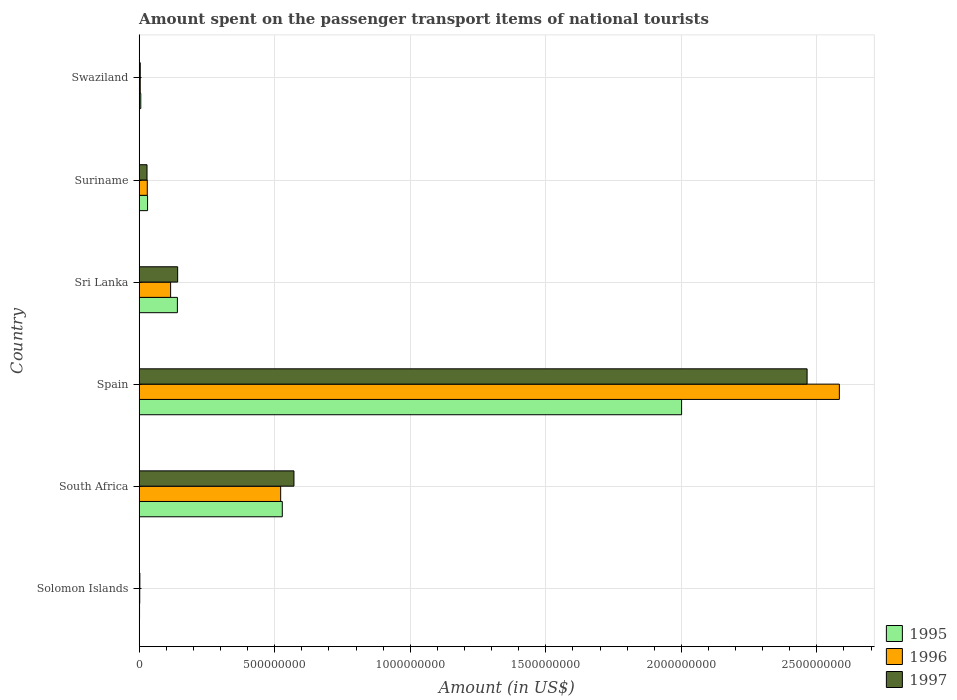How many groups of bars are there?
Ensure brevity in your answer.  6. How many bars are there on the 6th tick from the top?
Keep it short and to the point. 3. How many bars are there on the 4th tick from the bottom?
Offer a terse response. 3. What is the label of the 6th group of bars from the top?
Offer a very short reply. Solomon Islands. What is the amount spent on the passenger transport items of national tourists in 1995 in Sri Lanka?
Your response must be concise. 1.41e+08. Across all countries, what is the maximum amount spent on the passenger transport items of national tourists in 1997?
Provide a short and direct response. 2.46e+09. Across all countries, what is the minimum amount spent on the passenger transport items of national tourists in 1996?
Ensure brevity in your answer.  2.10e+06. In which country was the amount spent on the passenger transport items of national tourists in 1997 minimum?
Your answer should be compact. Solomon Islands. What is the total amount spent on the passenger transport items of national tourists in 1997 in the graph?
Your answer should be compact. 3.21e+09. What is the difference between the amount spent on the passenger transport items of national tourists in 1995 in Solomon Islands and that in Spain?
Provide a short and direct response. -2.00e+09. What is the difference between the amount spent on the passenger transport items of national tourists in 1995 in Solomon Islands and the amount spent on the passenger transport items of national tourists in 1997 in Suriname?
Provide a short and direct response. -2.76e+07. What is the average amount spent on the passenger transport items of national tourists in 1996 per country?
Give a very brief answer. 5.43e+08. In how many countries, is the amount spent on the passenger transport items of national tourists in 1996 greater than 2100000000 US$?
Keep it short and to the point. 1. What is the ratio of the amount spent on the passenger transport items of national tourists in 1996 in Solomon Islands to that in Swaziland?
Your answer should be very brief. 0.53. Is the amount spent on the passenger transport items of national tourists in 1997 in South Africa less than that in Spain?
Offer a very short reply. Yes. Is the difference between the amount spent on the passenger transport items of national tourists in 1997 in South Africa and Swaziland greater than the difference between the amount spent on the passenger transport items of national tourists in 1995 in South Africa and Swaziland?
Provide a short and direct response. Yes. What is the difference between the highest and the second highest amount spent on the passenger transport items of national tourists in 1996?
Your response must be concise. 2.06e+09. What is the difference between the highest and the lowest amount spent on the passenger transport items of national tourists in 1995?
Your response must be concise. 2.00e+09. Is the sum of the amount spent on the passenger transport items of national tourists in 1995 in Sri Lanka and Swaziland greater than the maximum amount spent on the passenger transport items of national tourists in 1997 across all countries?
Your response must be concise. No. What does the 1st bar from the bottom in Sri Lanka represents?
Your answer should be compact. 1995. Are all the bars in the graph horizontal?
Provide a succinct answer. Yes. How many countries are there in the graph?
Offer a terse response. 6. Are the values on the major ticks of X-axis written in scientific E-notation?
Your answer should be compact. No. Does the graph contain grids?
Give a very brief answer. Yes. Where does the legend appear in the graph?
Make the answer very short. Bottom right. How are the legend labels stacked?
Provide a succinct answer. Vertical. What is the title of the graph?
Keep it short and to the point. Amount spent on the passenger transport items of national tourists. What is the label or title of the X-axis?
Offer a very short reply. Amount (in US$). What is the Amount (in US$) of 1995 in Solomon Islands?
Provide a succinct answer. 1.40e+06. What is the Amount (in US$) in 1996 in Solomon Islands?
Provide a short and direct response. 2.10e+06. What is the Amount (in US$) of 1997 in Solomon Islands?
Make the answer very short. 2.60e+06. What is the Amount (in US$) of 1995 in South Africa?
Keep it short and to the point. 5.28e+08. What is the Amount (in US$) in 1996 in South Africa?
Your answer should be compact. 5.22e+08. What is the Amount (in US$) in 1997 in South Africa?
Your answer should be compact. 5.71e+08. What is the Amount (in US$) in 1995 in Spain?
Make the answer very short. 2.00e+09. What is the Amount (in US$) in 1996 in Spain?
Your answer should be compact. 2.58e+09. What is the Amount (in US$) of 1997 in Spain?
Your answer should be compact. 2.46e+09. What is the Amount (in US$) of 1995 in Sri Lanka?
Provide a succinct answer. 1.41e+08. What is the Amount (in US$) in 1996 in Sri Lanka?
Ensure brevity in your answer.  1.16e+08. What is the Amount (in US$) in 1997 in Sri Lanka?
Provide a short and direct response. 1.42e+08. What is the Amount (in US$) in 1995 in Suriname?
Keep it short and to the point. 3.10e+07. What is the Amount (in US$) of 1996 in Suriname?
Your answer should be compact. 3.00e+07. What is the Amount (in US$) of 1997 in Suriname?
Provide a succinct answer. 2.90e+07. What is the Amount (in US$) of 1995 in Swaziland?
Provide a succinct answer. 6.00e+06. Across all countries, what is the maximum Amount (in US$) in 1995?
Your response must be concise. 2.00e+09. Across all countries, what is the maximum Amount (in US$) of 1996?
Provide a succinct answer. 2.58e+09. Across all countries, what is the maximum Amount (in US$) of 1997?
Offer a terse response. 2.46e+09. Across all countries, what is the minimum Amount (in US$) of 1995?
Keep it short and to the point. 1.40e+06. Across all countries, what is the minimum Amount (in US$) in 1996?
Offer a terse response. 2.10e+06. Across all countries, what is the minimum Amount (in US$) of 1997?
Give a very brief answer. 2.60e+06. What is the total Amount (in US$) of 1995 in the graph?
Offer a very short reply. 2.71e+09. What is the total Amount (in US$) in 1996 in the graph?
Provide a succinct answer. 3.26e+09. What is the total Amount (in US$) in 1997 in the graph?
Keep it short and to the point. 3.21e+09. What is the difference between the Amount (in US$) of 1995 in Solomon Islands and that in South Africa?
Ensure brevity in your answer.  -5.27e+08. What is the difference between the Amount (in US$) in 1996 in Solomon Islands and that in South Africa?
Provide a succinct answer. -5.20e+08. What is the difference between the Amount (in US$) in 1997 in Solomon Islands and that in South Africa?
Offer a very short reply. -5.68e+08. What is the difference between the Amount (in US$) of 1995 in Solomon Islands and that in Spain?
Ensure brevity in your answer.  -2.00e+09. What is the difference between the Amount (in US$) in 1996 in Solomon Islands and that in Spain?
Provide a succinct answer. -2.58e+09. What is the difference between the Amount (in US$) in 1997 in Solomon Islands and that in Spain?
Your response must be concise. -2.46e+09. What is the difference between the Amount (in US$) in 1995 in Solomon Islands and that in Sri Lanka?
Give a very brief answer. -1.40e+08. What is the difference between the Amount (in US$) in 1996 in Solomon Islands and that in Sri Lanka?
Your response must be concise. -1.14e+08. What is the difference between the Amount (in US$) of 1997 in Solomon Islands and that in Sri Lanka?
Offer a terse response. -1.39e+08. What is the difference between the Amount (in US$) of 1995 in Solomon Islands and that in Suriname?
Your response must be concise. -2.96e+07. What is the difference between the Amount (in US$) of 1996 in Solomon Islands and that in Suriname?
Your response must be concise. -2.79e+07. What is the difference between the Amount (in US$) of 1997 in Solomon Islands and that in Suriname?
Provide a succinct answer. -2.64e+07. What is the difference between the Amount (in US$) of 1995 in Solomon Islands and that in Swaziland?
Provide a succinct answer. -4.60e+06. What is the difference between the Amount (in US$) in 1996 in Solomon Islands and that in Swaziland?
Make the answer very short. -1.90e+06. What is the difference between the Amount (in US$) in 1997 in Solomon Islands and that in Swaziland?
Make the answer very short. -1.40e+06. What is the difference between the Amount (in US$) of 1995 in South Africa and that in Spain?
Provide a short and direct response. -1.47e+09. What is the difference between the Amount (in US$) in 1996 in South Africa and that in Spain?
Make the answer very short. -2.06e+09. What is the difference between the Amount (in US$) in 1997 in South Africa and that in Spain?
Provide a short and direct response. -1.89e+09. What is the difference between the Amount (in US$) in 1995 in South Africa and that in Sri Lanka?
Keep it short and to the point. 3.87e+08. What is the difference between the Amount (in US$) of 1996 in South Africa and that in Sri Lanka?
Your response must be concise. 4.06e+08. What is the difference between the Amount (in US$) of 1997 in South Africa and that in Sri Lanka?
Your response must be concise. 4.29e+08. What is the difference between the Amount (in US$) in 1995 in South Africa and that in Suriname?
Keep it short and to the point. 4.97e+08. What is the difference between the Amount (in US$) in 1996 in South Africa and that in Suriname?
Provide a short and direct response. 4.92e+08. What is the difference between the Amount (in US$) of 1997 in South Africa and that in Suriname?
Your response must be concise. 5.42e+08. What is the difference between the Amount (in US$) in 1995 in South Africa and that in Swaziland?
Provide a succinct answer. 5.22e+08. What is the difference between the Amount (in US$) of 1996 in South Africa and that in Swaziland?
Make the answer very short. 5.18e+08. What is the difference between the Amount (in US$) of 1997 in South Africa and that in Swaziland?
Provide a succinct answer. 5.67e+08. What is the difference between the Amount (in US$) of 1995 in Spain and that in Sri Lanka?
Make the answer very short. 1.86e+09. What is the difference between the Amount (in US$) of 1996 in Spain and that in Sri Lanka?
Provide a short and direct response. 2.47e+09. What is the difference between the Amount (in US$) of 1997 in Spain and that in Sri Lanka?
Offer a terse response. 2.32e+09. What is the difference between the Amount (in US$) of 1995 in Spain and that in Suriname?
Give a very brief answer. 1.97e+09. What is the difference between the Amount (in US$) in 1996 in Spain and that in Suriname?
Your answer should be very brief. 2.55e+09. What is the difference between the Amount (in US$) of 1997 in Spain and that in Suriname?
Offer a terse response. 2.44e+09. What is the difference between the Amount (in US$) of 1995 in Spain and that in Swaziland?
Keep it short and to the point. 2.00e+09. What is the difference between the Amount (in US$) in 1996 in Spain and that in Swaziland?
Your response must be concise. 2.58e+09. What is the difference between the Amount (in US$) in 1997 in Spain and that in Swaziland?
Ensure brevity in your answer.  2.46e+09. What is the difference between the Amount (in US$) in 1995 in Sri Lanka and that in Suriname?
Your response must be concise. 1.10e+08. What is the difference between the Amount (in US$) of 1996 in Sri Lanka and that in Suriname?
Provide a succinct answer. 8.60e+07. What is the difference between the Amount (in US$) in 1997 in Sri Lanka and that in Suriname?
Offer a terse response. 1.13e+08. What is the difference between the Amount (in US$) in 1995 in Sri Lanka and that in Swaziland?
Your answer should be very brief. 1.35e+08. What is the difference between the Amount (in US$) in 1996 in Sri Lanka and that in Swaziland?
Offer a very short reply. 1.12e+08. What is the difference between the Amount (in US$) of 1997 in Sri Lanka and that in Swaziland?
Provide a succinct answer. 1.38e+08. What is the difference between the Amount (in US$) in 1995 in Suriname and that in Swaziland?
Offer a terse response. 2.50e+07. What is the difference between the Amount (in US$) of 1996 in Suriname and that in Swaziland?
Offer a very short reply. 2.60e+07. What is the difference between the Amount (in US$) in 1997 in Suriname and that in Swaziland?
Provide a short and direct response. 2.50e+07. What is the difference between the Amount (in US$) of 1995 in Solomon Islands and the Amount (in US$) of 1996 in South Africa?
Keep it short and to the point. -5.21e+08. What is the difference between the Amount (in US$) in 1995 in Solomon Islands and the Amount (in US$) in 1997 in South Africa?
Provide a succinct answer. -5.70e+08. What is the difference between the Amount (in US$) in 1996 in Solomon Islands and the Amount (in US$) in 1997 in South Africa?
Your answer should be compact. -5.69e+08. What is the difference between the Amount (in US$) of 1995 in Solomon Islands and the Amount (in US$) of 1996 in Spain?
Your answer should be compact. -2.58e+09. What is the difference between the Amount (in US$) of 1995 in Solomon Islands and the Amount (in US$) of 1997 in Spain?
Give a very brief answer. -2.46e+09. What is the difference between the Amount (in US$) in 1996 in Solomon Islands and the Amount (in US$) in 1997 in Spain?
Your response must be concise. -2.46e+09. What is the difference between the Amount (in US$) in 1995 in Solomon Islands and the Amount (in US$) in 1996 in Sri Lanka?
Ensure brevity in your answer.  -1.15e+08. What is the difference between the Amount (in US$) of 1995 in Solomon Islands and the Amount (in US$) of 1997 in Sri Lanka?
Your answer should be compact. -1.41e+08. What is the difference between the Amount (in US$) of 1996 in Solomon Islands and the Amount (in US$) of 1997 in Sri Lanka?
Ensure brevity in your answer.  -1.40e+08. What is the difference between the Amount (in US$) of 1995 in Solomon Islands and the Amount (in US$) of 1996 in Suriname?
Ensure brevity in your answer.  -2.86e+07. What is the difference between the Amount (in US$) of 1995 in Solomon Islands and the Amount (in US$) of 1997 in Suriname?
Ensure brevity in your answer.  -2.76e+07. What is the difference between the Amount (in US$) in 1996 in Solomon Islands and the Amount (in US$) in 1997 in Suriname?
Offer a very short reply. -2.69e+07. What is the difference between the Amount (in US$) in 1995 in Solomon Islands and the Amount (in US$) in 1996 in Swaziland?
Keep it short and to the point. -2.60e+06. What is the difference between the Amount (in US$) in 1995 in Solomon Islands and the Amount (in US$) in 1997 in Swaziland?
Your answer should be compact. -2.60e+06. What is the difference between the Amount (in US$) in 1996 in Solomon Islands and the Amount (in US$) in 1997 in Swaziland?
Ensure brevity in your answer.  -1.90e+06. What is the difference between the Amount (in US$) in 1995 in South Africa and the Amount (in US$) in 1996 in Spain?
Your answer should be compact. -2.06e+09. What is the difference between the Amount (in US$) in 1995 in South Africa and the Amount (in US$) in 1997 in Spain?
Offer a terse response. -1.94e+09. What is the difference between the Amount (in US$) in 1996 in South Africa and the Amount (in US$) in 1997 in Spain?
Keep it short and to the point. -1.94e+09. What is the difference between the Amount (in US$) of 1995 in South Africa and the Amount (in US$) of 1996 in Sri Lanka?
Provide a succinct answer. 4.12e+08. What is the difference between the Amount (in US$) in 1995 in South Africa and the Amount (in US$) in 1997 in Sri Lanka?
Ensure brevity in your answer.  3.86e+08. What is the difference between the Amount (in US$) of 1996 in South Africa and the Amount (in US$) of 1997 in Sri Lanka?
Keep it short and to the point. 3.80e+08. What is the difference between the Amount (in US$) of 1995 in South Africa and the Amount (in US$) of 1996 in Suriname?
Make the answer very short. 4.98e+08. What is the difference between the Amount (in US$) in 1995 in South Africa and the Amount (in US$) in 1997 in Suriname?
Provide a succinct answer. 4.99e+08. What is the difference between the Amount (in US$) in 1996 in South Africa and the Amount (in US$) in 1997 in Suriname?
Provide a succinct answer. 4.93e+08. What is the difference between the Amount (in US$) in 1995 in South Africa and the Amount (in US$) in 1996 in Swaziland?
Offer a very short reply. 5.24e+08. What is the difference between the Amount (in US$) in 1995 in South Africa and the Amount (in US$) in 1997 in Swaziland?
Offer a very short reply. 5.24e+08. What is the difference between the Amount (in US$) of 1996 in South Africa and the Amount (in US$) of 1997 in Swaziland?
Offer a very short reply. 5.18e+08. What is the difference between the Amount (in US$) of 1995 in Spain and the Amount (in US$) of 1996 in Sri Lanka?
Your answer should be very brief. 1.88e+09. What is the difference between the Amount (in US$) in 1995 in Spain and the Amount (in US$) in 1997 in Sri Lanka?
Your answer should be very brief. 1.86e+09. What is the difference between the Amount (in US$) of 1996 in Spain and the Amount (in US$) of 1997 in Sri Lanka?
Provide a succinct answer. 2.44e+09. What is the difference between the Amount (in US$) in 1995 in Spain and the Amount (in US$) in 1996 in Suriname?
Offer a terse response. 1.97e+09. What is the difference between the Amount (in US$) of 1995 in Spain and the Amount (in US$) of 1997 in Suriname?
Your answer should be compact. 1.97e+09. What is the difference between the Amount (in US$) in 1996 in Spain and the Amount (in US$) in 1997 in Suriname?
Give a very brief answer. 2.55e+09. What is the difference between the Amount (in US$) in 1995 in Spain and the Amount (in US$) in 1996 in Swaziland?
Ensure brevity in your answer.  2.00e+09. What is the difference between the Amount (in US$) in 1995 in Spain and the Amount (in US$) in 1997 in Swaziland?
Your answer should be compact. 2.00e+09. What is the difference between the Amount (in US$) in 1996 in Spain and the Amount (in US$) in 1997 in Swaziland?
Your answer should be compact. 2.58e+09. What is the difference between the Amount (in US$) in 1995 in Sri Lanka and the Amount (in US$) in 1996 in Suriname?
Give a very brief answer. 1.11e+08. What is the difference between the Amount (in US$) of 1995 in Sri Lanka and the Amount (in US$) of 1997 in Suriname?
Make the answer very short. 1.12e+08. What is the difference between the Amount (in US$) of 1996 in Sri Lanka and the Amount (in US$) of 1997 in Suriname?
Provide a short and direct response. 8.70e+07. What is the difference between the Amount (in US$) in 1995 in Sri Lanka and the Amount (in US$) in 1996 in Swaziland?
Ensure brevity in your answer.  1.37e+08. What is the difference between the Amount (in US$) in 1995 in Sri Lanka and the Amount (in US$) in 1997 in Swaziland?
Give a very brief answer. 1.37e+08. What is the difference between the Amount (in US$) of 1996 in Sri Lanka and the Amount (in US$) of 1997 in Swaziland?
Give a very brief answer. 1.12e+08. What is the difference between the Amount (in US$) of 1995 in Suriname and the Amount (in US$) of 1996 in Swaziland?
Offer a very short reply. 2.70e+07. What is the difference between the Amount (in US$) of 1995 in Suriname and the Amount (in US$) of 1997 in Swaziland?
Offer a very short reply. 2.70e+07. What is the difference between the Amount (in US$) of 1996 in Suriname and the Amount (in US$) of 1997 in Swaziland?
Provide a short and direct response. 2.60e+07. What is the average Amount (in US$) of 1995 per country?
Your response must be concise. 4.51e+08. What is the average Amount (in US$) in 1996 per country?
Your answer should be compact. 5.43e+08. What is the average Amount (in US$) of 1997 per country?
Make the answer very short. 5.35e+08. What is the difference between the Amount (in US$) of 1995 and Amount (in US$) of 1996 in Solomon Islands?
Offer a very short reply. -7.00e+05. What is the difference between the Amount (in US$) of 1995 and Amount (in US$) of 1997 in Solomon Islands?
Provide a short and direct response. -1.20e+06. What is the difference between the Amount (in US$) of 1996 and Amount (in US$) of 1997 in Solomon Islands?
Your answer should be very brief. -5.00e+05. What is the difference between the Amount (in US$) of 1995 and Amount (in US$) of 1997 in South Africa?
Provide a short and direct response. -4.30e+07. What is the difference between the Amount (in US$) of 1996 and Amount (in US$) of 1997 in South Africa?
Ensure brevity in your answer.  -4.90e+07. What is the difference between the Amount (in US$) in 1995 and Amount (in US$) in 1996 in Spain?
Provide a short and direct response. -5.82e+08. What is the difference between the Amount (in US$) in 1995 and Amount (in US$) in 1997 in Spain?
Offer a terse response. -4.63e+08. What is the difference between the Amount (in US$) in 1996 and Amount (in US$) in 1997 in Spain?
Your answer should be compact. 1.19e+08. What is the difference between the Amount (in US$) of 1995 and Amount (in US$) of 1996 in Sri Lanka?
Make the answer very short. 2.50e+07. What is the difference between the Amount (in US$) of 1995 and Amount (in US$) of 1997 in Sri Lanka?
Your answer should be compact. -1.00e+06. What is the difference between the Amount (in US$) in 1996 and Amount (in US$) in 1997 in Sri Lanka?
Your answer should be very brief. -2.60e+07. What is the difference between the Amount (in US$) of 1995 and Amount (in US$) of 1997 in Suriname?
Your answer should be compact. 2.00e+06. What is the difference between the Amount (in US$) of 1996 and Amount (in US$) of 1997 in Suriname?
Ensure brevity in your answer.  1.00e+06. What is the difference between the Amount (in US$) in 1995 and Amount (in US$) in 1996 in Swaziland?
Make the answer very short. 2.00e+06. What is the difference between the Amount (in US$) of 1995 and Amount (in US$) of 1997 in Swaziland?
Offer a terse response. 2.00e+06. What is the difference between the Amount (in US$) in 1996 and Amount (in US$) in 1997 in Swaziland?
Make the answer very short. 0. What is the ratio of the Amount (in US$) of 1995 in Solomon Islands to that in South Africa?
Keep it short and to the point. 0. What is the ratio of the Amount (in US$) in 1996 in Solomon Islands to that in South Africa?
Offer a very short reply. 0. What is the ratio of the Amount (in US$) in 1997 in Solomon Islands to that in South Africa?
Your response must be concise. 0. What is the ratio of the Amount (in US$) in 1995 in Solomon Islands to that in Spain?
Your answer should be compact. 0. What is the ratio of the Amount (in US$) in 1996 in Solomon Islands to that in Spain?
Give a very brief answer. 0. What is the ratio of the Amount (in US$) of 1997 in Solomon Islands to that in Spain?
Keep it short and to the point. 0. What is the ratio of the Amount (in US$) in 1995 in Solomon Islands to that in Sri Lanka?
Offer a terse response. 0.01. What is the ratio of the Amount (in US$) of 1996 in Solomon Islands to that in Sri Lanka?
Give a very brief answer. 0.02. What is the ratio of the Amount (in US$) in 1997 in Solomon Islands to that in Sri Lanka?
Your answer should be very brief. 0.02. What is the ratio of the Amount (in US$) of 1995 in Solomon Islands to that in Suriname?
Give a very brief answer. 0.05. What is the ratio of the Amount (in US$) of 1996 in Solomon Islands to that in Suriname?
Make the answer very short. 0.07. What is the ratio of the Amount (in US$) in 1997 in Solomon Islands to that in Suriname?
Your answer should be very brief. 0.09. What is the ratio of the Amount (in US$) of 1995 in Solomon Islands to that in Swaziland?
Provide a succinct answer. 0.23. What is the ratio of the Amount (in US$) in 1996 in Solomon Islands to that in Swaziland?
Make the answer very short. 0.53. What is the ratio of the Amount (in US$) of 1997 in Solomon Islands to that in Swaziland?
Your answer should be compact. 0.65. What is the ratio of the Amount (in US$) of 1995 in South Africa to that in Spain?
Your answer should be very brief. 0.26. What is the ratio of the Amount (in US$) in 1996 in South Africa to that in Spain?
Offer a very short reply. 0.2. What is the ratio of the Amount (in US$) of 1997 in South Africa to that in Spain?
Your answer should be compact. 0.23. What is the ratio of the Amount (in US$) in 1995 in South Africa to that in Sri Lanka?
Your response must be concise. 3.74. What is the ratio of the Amount (in US$) of 1996 in South Africa to that in Sri Lanka?
Offer a terse response. 4.5. What is the ratio of the Amount (in US$) of 1997 in South Africa to that in Sri Lanka?
Offer a terse response. 4.02. What is the ratio of the Amount (in US$) in 1995 in South Africa to that in Suriname?
Provide a succinct answer. 17.03. What is the ratio of the Amount (in US$) in 1997 in South Africa to that in Suriname?
Provide a succinct answer. 19.69. What is the ratio of the Amount (in US$) of 1995 in South Africa to that in Swaziland?
Provide a short and direct response. 88. What is the ratio of the Amount (in US$) in 1996 in South Africa to that in Swaziland?
Your response must be concise. 130.5. What is the ratio of the Amount (in US$) of 1997 in South Africa to that in Swaziland?
Keep it short and to the point. 142.75. What is the ratio of the Amount (in US$) of 1995 in Spain to that in Sri Lanka?
Your answer should be very brief. 14.19. What is the ratio of the Amount (in US$) of 1996 in Spain to that in Sri Lanka?
Offer a very short reply. 22.27. What is the ratio of the Amount (in US$) of 1997 in Spain to that in Sri Lanka?
Make the answer very short. 17.35. What is the ratio of the Amount (in US$) in 1995 in Spain to that in Suriname?
Your response must be concise. 64.55. What is the ratio of the Amount (in US$) in 1996 in Spain to that in Suriname?
Your answer should be compact. 86.1. What is the ratio of the Amount (in US$) of 1997 in Spain to that in Suriname?
Keep it short and to the point. 84.97. What is the ratio of the Amount (in US$) of 1995 in Spain to that in Swaziland?
Keep it short and to the point. 333.5. What is the ratio of the Amount (in US$) in 1996 in Spain to that in Swaziland?
Your answer should be compact. 645.75. What is the ratio of the Amount (in US$) of 1997 in Spain to that in Swaziland?
Make the answer very short. 616. What is the ratio of the Amount (in US$) in 1995 in Sri Lanka to that in Suriname?
Offer a terse response. 4.55. What is the ratio of the Amount (in US$) in 1996 in Sri Lanka to that in Suriname?
Your answer should be compact. 3.87. What is the ratio of the Amount (in US$) of 1997 in Sri Lanka to that in Suriname?
Ensure brevity in your answer.  4.9. What is the ratio of the Amount (in US$) in 1997 in Sri Lanka to that in Swaziland?
Provide a succinct answer. 35.5. What is the ratio of the Amount (in US$) of 1995 in Suriname to that in Swaziland?
Provide a short and direct response. 5.17. What is the ratio of the Amount (in US$) of 1997 in Suriname to that in Swaziland?
Offer a very short reply. 7.25. What is the difference between the highest and the second highest Amount (in US$) of 1995?
Your answer should be compact. 1.47e+09. What is the difference between the highest and the second highest Amount (in US$) of 1996?
Offer a terse response. 2.06e+09. What is the difference between the highest and the second highest Amount (in US$) of 1997?
Keep it short and to the point. 1.89e+09. What is the difference between the highest and the lowest Amount (in US$) of 1995?
Provide a succinct answer. 2.00e+09. What is the difference between the highest and the lowest Amount (in US$) in 1996?
Provide a short and direct response. 2.58e+09. What is the difference between the highest and the lowest Amount (in US$) of 1997?
Ensure brevity in your answer.  2.46e+09. 